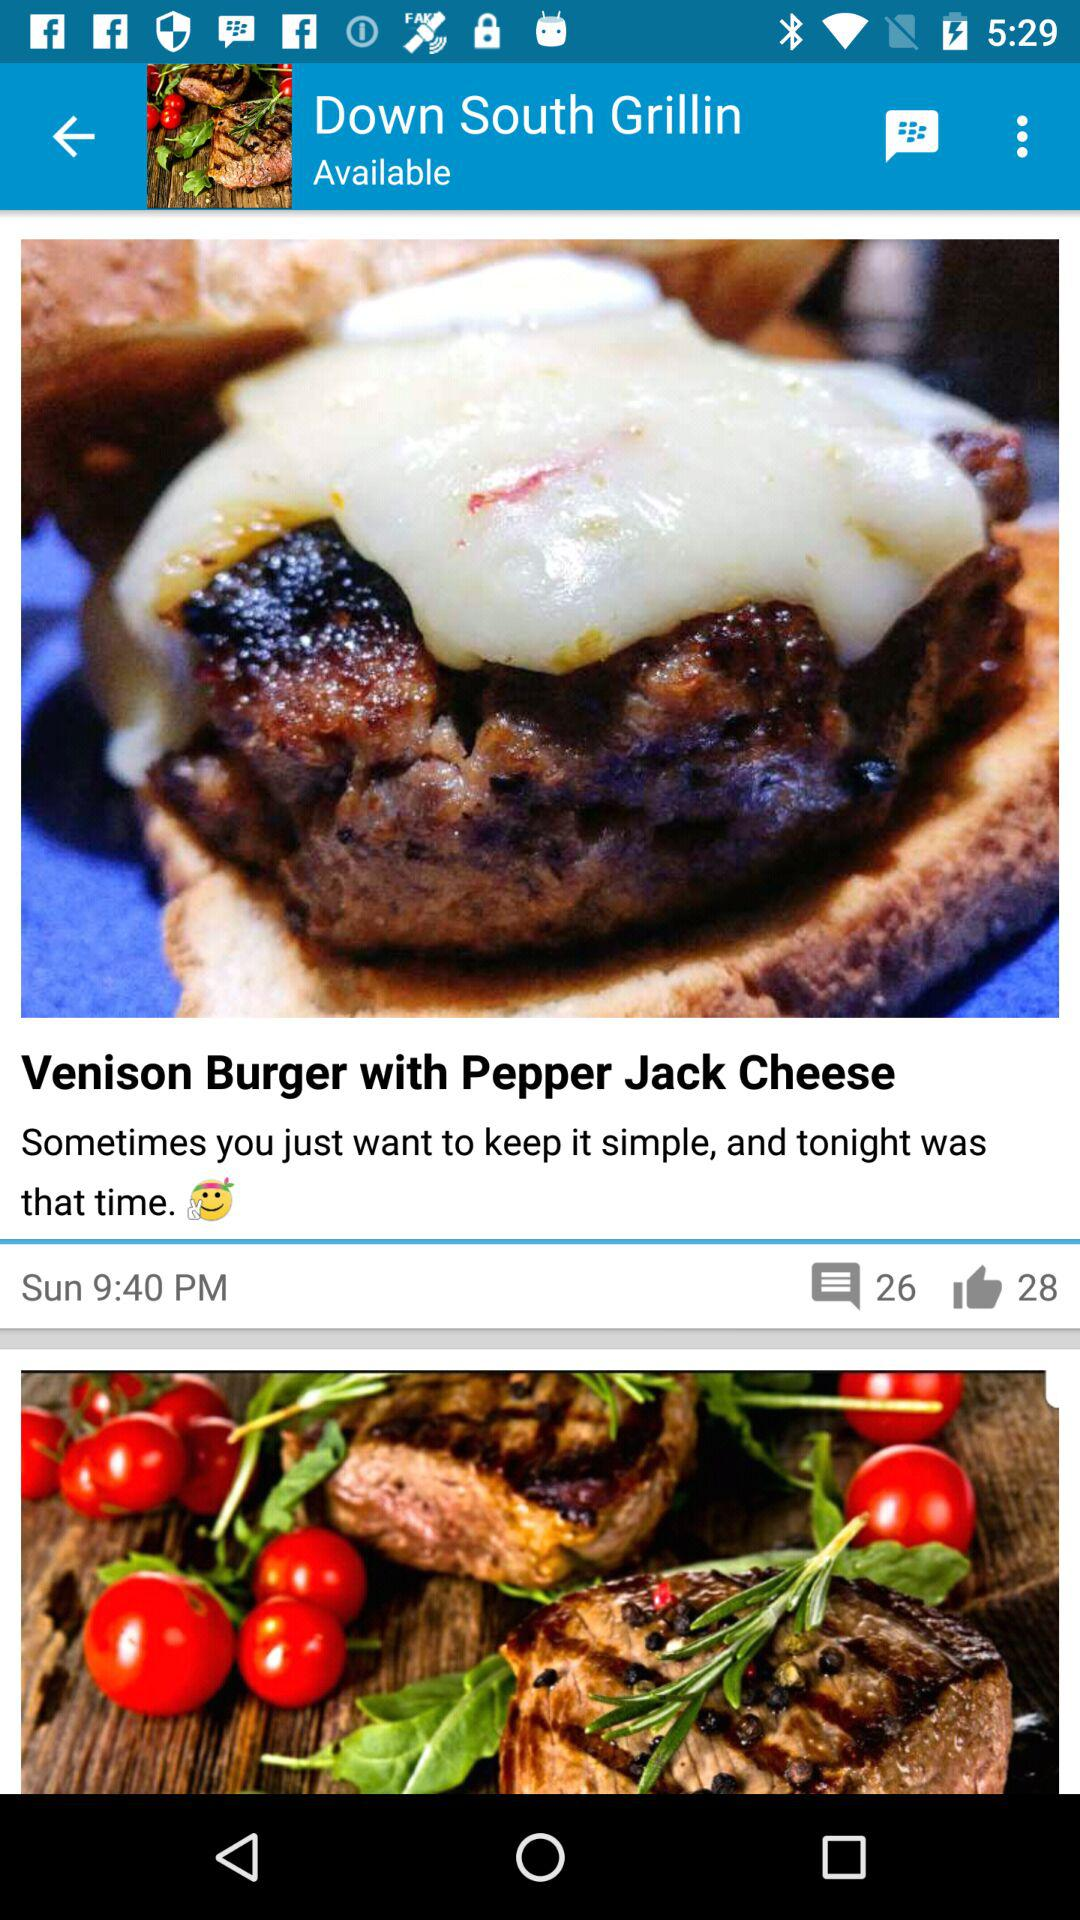What is the posted time of the post? The posted time of the post is 9:40 PM. 